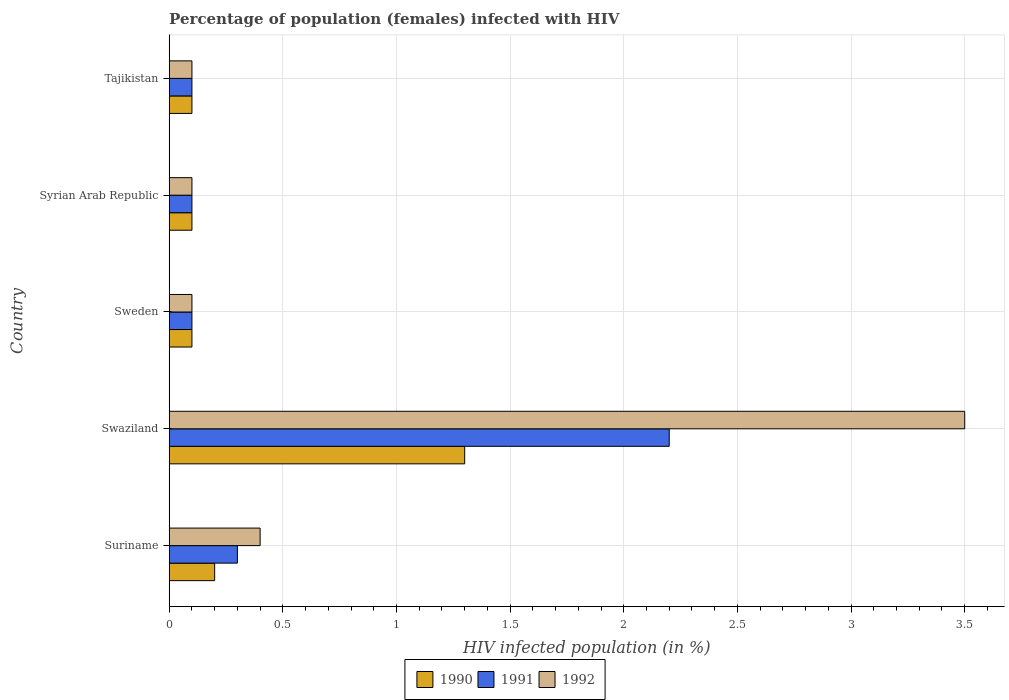How many different coloured bars are there?
Make the answer very short. 3. Are the number of bars per tick equal to the number of legend labels?
Your answer should be compact. Yes. How many bars are there on the 5th tick from the top?
Your answer should be very brief. 3. How many bars are there on the 2nd tick from the bottom?
Keep it short and to the point. 3. What is the label of the 3rd group of bars from the top?
Provide a succinct answer. Sweden. In how many cases, is the number of bars for a given country not equal to the number of legend labels?
Provide a short and direct response. 0. What is the percentage of HIV infected female population in 1992 in Swaziland?
Your answer should be compact. 3.5. In which country was the percentage of HIV infected female population in 1990 maximum?
Offer a terse response. Swaziland. What is the total percentage of HIV infected female population in 1990 in the graph?
Give a very brief answer. 1.8. What is the difference between the percentage of HIV infected female population in 1991 in Suriname and that in Tajikistan?
Your answer should be very brief. 0.2. What is the difference between the percentage of HIV infected female population in 1992 in Tajikistan and the percentage of HIV infected female population in 1991 in Swaziland?
Ensure brevity in your answer.  -2.1. What is the average percentage of HIV infected female population in 1992 per country?
Your answer should be compact. 0.84. What is the difference between the percentage of HIV infected female population in 1990 and percentage of HIV infected female population in 1992 in Tajikistan?
Provide a short and direct response. 0. Is the difference between the percentage of HIV infected female population in 1990 in Suriname and Syrian Arab Republic greater than the difference between the percentage of HIV infected female population in 1992 in Suriname and Syrian Arab Republic?
Your answer should be compact. No. What is the difference between the highest and the second highest percentage of HIV infected female population in 1991?
Provide a succinct answer. 1.9. What is the difference between the highest and the lowest percentage of HIV infected female population in 1992?
Your answer should be very brief. 3.4. In how many countries, is the percentage of HIV infected female population in 1990 greater than the average percentage of HIV infected female population in 1990 taken over all countries?
Provide a succinct answer. 1. What does the 2nd bar from the bottom in Swaziland represents?
Make the answer very short. 1991. Is it the case that in every country, the sum of the percentage of HIV infected female population in 1990 and percentage of HIV infected female population in 1991 is greater than the percentage of HIV infected female population in 1992?
Provide a short and direct response. No. Are all the bars in the graph horizontal?
Give a very brief answer. Yes. How many countries are there in the graph?
Offer a very short reply. 5. Does the graph contain grids?
Offer a very short reply. Yes. Where does the legend appear in the graph?
Keep it short and to the point. Bottom center. How are the legend labels stacked?
Your response must be concise. Horizontal. What is the title of the graph?
Give a very brief answer. Percentage of population (females) infected with HIV. What is the label or title of the X-axis?
Offer a terse response. HIV infected population (in %). What is the label or title of the Y-axis?
Give a very brief answer. Country. What is the HIV infected population (in %) of 1990 in Suriname?
Your answer should be very brief. 0.2. What is the HIV infected population (in %) in 1991 in Suriname?
Ensure brevity in your answer.  0.3. What is the HIV infected population (in %) in 1990 in Swaziland?
Ensure brevity in your answer.  1.3. What is the HIV infected population (in %) of 1992 in Swaziland?
Give a very brief answer. 3.5. What is the HIV infected population (in %) in 1990 in Sweden?
Offer a terse response. 0.1. What is the HIV infected population (in %) of 1991 in Sweden?
Your answer should be compact. 0.1. What is the HIV infected population (in %) of 1992 in Sweden?
Give a very brief answer. 0.1. What is the HIV infected population (in %) in 1990 in Syrian Arab Republic?
Offer a very short reply. 0.1. What is the HIV infected population (in %) in 1991 in Tajikistan?
Your answer should be very brief. 0.1. What is the HIV infected population (in %) in 1992 in Tajikistan?
Make the answer very short. 0.1. Across all countries, what is the maximum HIV infected population (in %) in 1991?
Offer a very short reply. 2.2. Across all countries, what is the maximum HIV infected population (in %) in 1992?
Your answer should be very brief. 3.5. Across all countries, what is the minimum HIV infected population (in %) in 1991?
Offer a terse response. 0.1. What is the total HIV infected population (in %) in 1990 in the graph?
Your answer should be very brief. 1.8. What is the total HIV infected population (in %) of 1991 in the graph?
Provide a short and direct response. 2.8. What is the total HIV infected population (in %) in 1992 in the graph?
Provide a succinct answer. 4.2. What is the difference between the HIV infected population (in %) of 1990 in Suriname and that in Swaziland?
Keep it short and to the point. -1.1. What is the difference between the HIV infected population (in %) of 1991 in Suriname and that in Swaziland?
Make the answer very short. -1.9. What is the difference between the HIV infected population (in %) in 1992 in Suriname and that in Swaziland?
Provide a short and direct response. -3.1. What is the difference between the HIV infected population (in %) of 1990 in Suriname and that in Sweden?
Offer a terse response. 0.1. What is the difference between the HIV infected population (in %) of 1991 in Suriname and that in Sweden?
Offer a terse response. 0.2. What is the difference between the HIV infected population (in %) in 1991 in Suriname and that in Syrian Arab Republic?
Your answer should be compact. 0.2. What is the difference between the HIV infected population (in %) of 1990 in Suriname and that in Tajikistan?
Ensure brevity in your answer.  0.1. What is the difference between the HIV infected population (in %) of 1992 in Suriname and that in Tajikistan?
Ensure brevity in your answer.  0.3. What is the difference between the HIV infected population (in %) in 1991 in Swaziland and that in Syrian Arab Republic?
Your response must be concise. 2.1. What is the difference between the HIV infected population (in %) of 1990 in Swaziland and that in Tajikistan?
Offer a very short reply. 1.2. What is the difference between the HIV infected population (in %) of 1991 in Swaziland and that in Tajikistan?
Make the answer very short. 2.1. What is the difference between the HIV infected population (in %) in 1992 in Swaziland and that in Tajikistan?
Your response must be concise. 3.4. What is the difference between the HIV infected population (in %) in 1991 in Sweden and that in Syrian Arab Republic?
Give a very brief answer. 0. What is the difference between the HIV infected population (in %) of 1992 in Sweden and that in Syrian Arab Republic?
Your answer should be very brief. 0. What is the difference between the HIV infected population (in %) in 1992 in Syrian Arab Republic and that in Tajikistan?
Offer a terse response. 0. What is the difference between the HIV infected population (in %) of 1990 in Suriname and the HIV infected population (in %) of 1991 in Swaziland?
Your answer should be compact. -2. What is the difference between the HIV infected population (in %) in 1990 in Suriname and the HIV infected population (in %) in 1992 in Swaziland?
Your response must be concise. -3.3. What is the difference between the HIV infected population (in %) in 1991 in Suriname and the HIV infected population (in %) in 1992 in Swaziland?
Your response must be concise. -3.2. What is the difference between the HIV infected population (in %) of 1990 in Suriname and the HIV infected population (in %) of 1991 in Syrian Arab Republic?
Ensure brevity in your answer.  0.1. What is the difference between the HIV infected population (in %) in 1991 in Suriname and the HIV infected population (in %) in 1992 in Syrian Arab Republic?
Provide a succinct answer. 0.2. What is the difference between the HIV infected population (in %) in 1990 in Suriname and the HIV infected population (in %) in 1992 in Tajikistan?
Offer a terse response. 0.1. What is the difference between the HIV infected population (in %) of 1991 in Suriname and the HIV infected population (in %) of 1992 in Tajikistan?
Ensure brevity in your answer.  0.2. What is the difference between the HIV infected population (in %) in 1991 in Swaziland and the HIV infected population (in %) in 1992 in Sweden?
Offer a very short reply. 2.1. What is the difference between the HIV infected population (in %) in 1990 in Swaziland and the HIV infected population (in %) in 1991 in Syrian Arab Republic?
Your answer should be very brief. 1.2. What is the difference between the HIV infected population (in %) of 1990 in Swaziland and the HIV infected population (in %) of 1992 in Syrian Arab Republic?
Your answer should be compact. 1.2. What is the difference between the HIV infected population (in %) of 1991 in Swaziland and the HIV infected population (in %) of 1992 in Syrian Arab Republic?
Make the answer very short. 2.1. What is the difference between the HIV infected population (in %) of 1990 in Swaziland and the HIV infected population (in %) of 1991 in Tajikistan?
Offer a terse response. 1.2. What is the difference between the HIV infected population (in %) of 1990 in Swaziland and the HIV infected population (in %) of 1992 in Tajikistan?
Give a very brief answer. 1.2. What is the difference between the HIV infected population (in %) in 1991 in Swaziland and the HIV infected population (in %) in 1992 in Tajikistan?
Make the answer very short. 2.1. What is the average HIV infected population (in %) of 1990 per country?
Your answer should be very brief. 0.36. What is the average HIV infected population (in %) in 1991 per country?
Ensure brevity in your answer.  0.56. What is the average HIV infected population (in %) in 1992 per country?
Offer a very short reply. 0.84. What is the difference between the HIV infected population (in %) of 1990 and HIV infected population (in %) of 1991 in Suriname?
Offer a terse response. -0.1. What is the difference between the HIV infected population (in %) in 1990 and HIV infected population (in %) in 1992 in Suriname?
Offer a very short reply. -0.2. What is the difference between the HIV infected population (in %) in 1991 and HIV infected population (in %) in 1992 in Suriname?
Provide a succinct answer. -0.1. What is the difference between the HIV infected population (in %) in 1990 and HIV infected population (in %) in 1991 in Sweden?
Give a very brief answer. 0. What is the difference between the HIV infected population (in %) in 1990 and HIV infected population (in %) in 1992 in Sweden?
Provide a succinct answer. 0. What is the difference between the HIV infected population (in %) of 1990 and HIV infected population (in %) of 1992 in Syrian Arab Republic?
Keep it short and to the point. 0. What is the difference between the HIV infected population (in %) in 1990 and HIV infected population (in %) in 1992 in Tajikistan?
Your answer should be compact. 0. What is the difference between the HIV infected population (in %) of 1991 and HIV infected population (in %) of 1992 in Tajikistan?
Offer a very short reply. 0. What is the ratio of the HIV infected population (in %) in 1990 in Suriname to that in Swaziland?
Provide a succinct answer. 0.15. What is the ratio of the HIV infected population (in %) of 1991 in Suriname to that in Swaziland?
Offer a terse response. 0.14. What is the ratio of the HIV infected population (in %) of 1992 in Suriname to that in Swaziland?
Offer a terse response. 0.11. What is the ratio of the HIV infected population (in %) in 1991 in Suriname to that in Syrian Arab Republic?
Your answer should be compact. 3. What is the ratio of the HIV infected population (in %) of 1990 in Suriname to that in Tajikistan?
Your answer should be very brief. 2. What is the ratio of the HIV infected population (in %) of 1991 in Suriname to that in Tajikistan?
Offer a very short reply. 3. What is the ratio of the HIV infected population (in %) of 1991 in Swaziland to that in Sweden?
Keep it short and to the point. 22. What is the ratio of the HIV infected population (in %) of 1992 in Swaziland to that in Sweden?
Provide a succinct answer. 35. What is the ratio of the HIV infected population (in %) of 1990 in Swaziland to that in Syrian Arab Republic?
Provide a short and direct response. 13. What is the ratio of the HIV infected population (in %) in 1991 in Swaziland to that in Syrian Arab Republic?
Provide a short and direct response. 22. What is the ratio of the HIV infected population (in %) of 1992 in Swaziland to that in Syrian Arab Republic?
Your response must be concise. 35. What is the ratio of the HIV infected population (in %) in 1990 in Swaziland to that in Tajikistan?
Provide a short and direct response. 13. What is the ratio of the HIV infected population (in %) in 1992 in Swaziland to that in Tajikistan?
Provide a succinct answer. 35. What is the ratio of the HIV infected population (in %) in 1992 in Sweden to that in Syrian Arab Republic?
Offer a terse response. 1. What is the ratio of the HIV infected population (in %) of 1991 in Syrian Arab Republic to that in Tajikistan?
Provide a succinct answer. 1. What is the ratio of the HIV infected population (in %) of 1992 in Syrian Arab Republic to that in Tajikistan?
Your answer should be very brief. 1. 